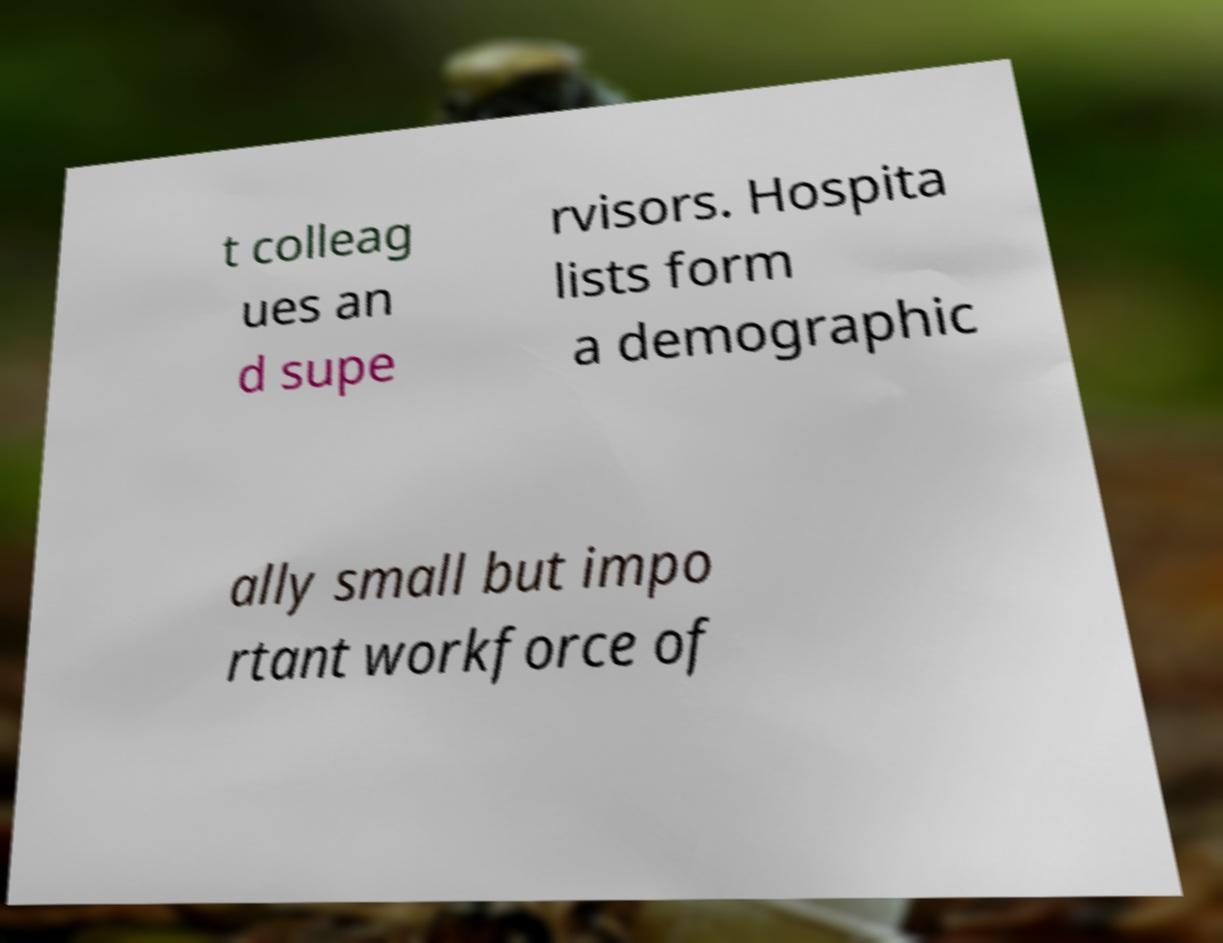Can you accurately transcribe the text from the provided image for me? t colleag ues an d supe rvisors. Hospita lists form a demographic ally small but impo rtant workforce of 